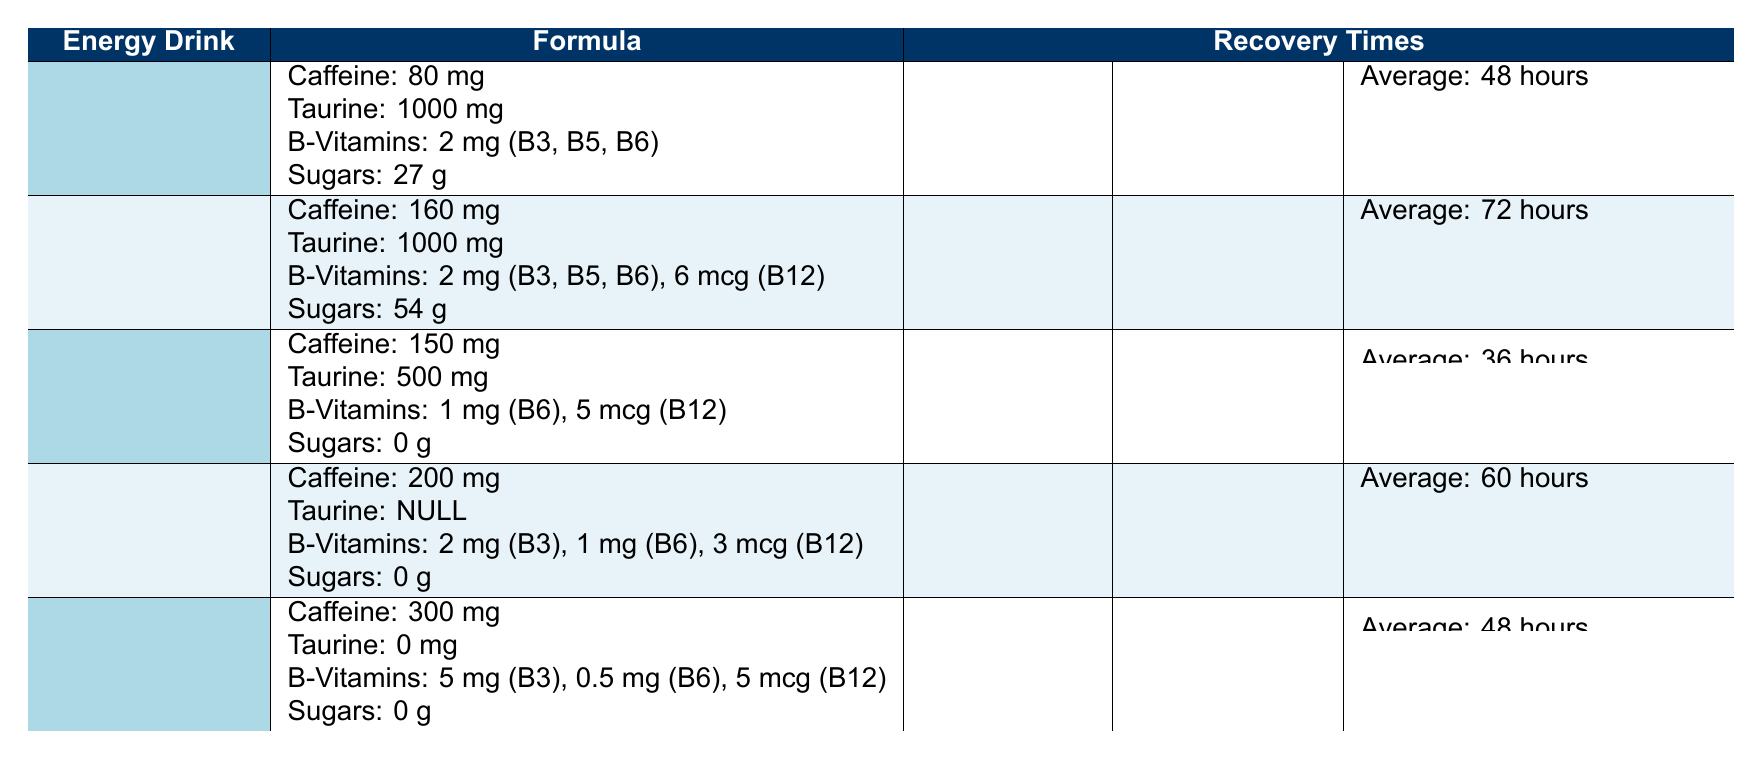What is the recovery time for athletes after using G Fuel? The recovery time for athletes after using G Fuel is listed in the table under "Average Recovery Time," which is 36 hours.
Answer: 36 hours Which energy drink has the longest average recovery time? By reviewing the average recovery times listed in the table, Monster Energy has the longest recovery time of 72 hours.
Answer: 72 hours True or False: C4 Energy contains any sugars. Looking at the formula for C4 Energy in the table, it is indicated that there are 0 grams of sugars. Therefore, the statement is false.
Answer: False How much caffeine is in Bang Energy? The amount of caffeine in Bang Energy can be found directly in the table, which states it contains 300 mg of caffeine.
Answer: 300 mg What is the difference in recovery time between Monster Energy and G Fuel? To find the difference, subtract the average recovery time of G Fuel (36 hours) from that of Monster Energy (72 hours): 72 - 36 = 36 hours.
Answer: 36 hours If an athlete uses Red Bull, what additional supplementation might they need? The notes provided in the table mention that Red Bull is effective for endurance, suggesting athletes may need additional electrolytes or nutrients after prolonged sessions.
Answer: Additional electrolytes or nutrients Which energy drink is a low-calorie option suitable for agility training? Referring to the table, G Fuel is noted as a low-calorie option ideal for agility training, as it has 0 grams of sugars and a lower recovery time.
Answer: G Fuel How many B-Vitamins does Monster Energy contain? The table lists that Monster Energy contains a total of 2 mg of B-Vitamins (B3, B5, B6) and 6 mcg of B12, summing these values together gives a total of 2 mg + 0.006 mg = 2.006 mg but primarily 2 mg is stated for the main B-Vitamins section.
Answer: 2 mg Which energy drink provides a larger amount of caffeine: C4 Energy or G Fuel? C4 Energy contains 200 mg of caffeine, while G Fuel contains 150 mg. Thus, comparing the two values shows C4 has more caffeine.
Answer: C4 Energy 